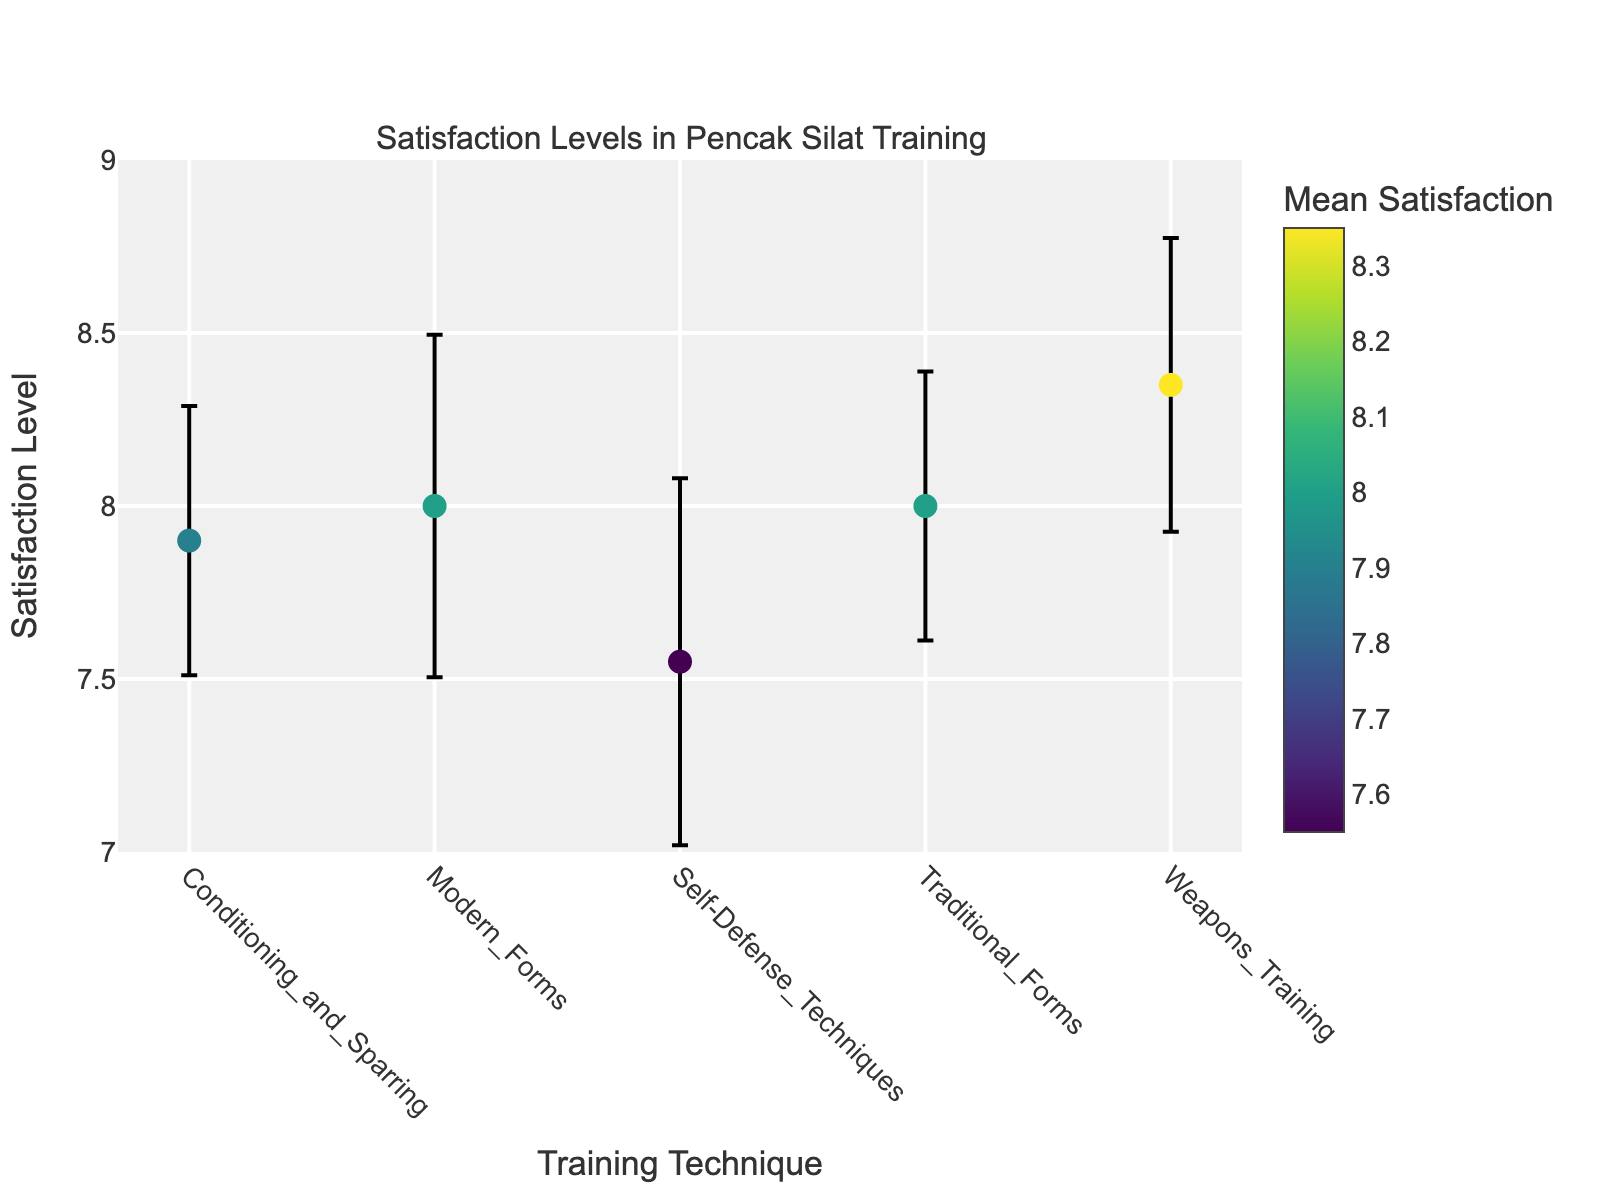What's the title of the plot? The title of the plot is located at the top of the figure. The subplot title is "Satisfaction Levels in Pencak Silat Training".
Answer: Satisfaction Levels in Pencak Silat Training Which training technique has the highest mean satisfaction level? The highest mean satisfaction level can be identified by the dot that is positioned the highest on the y-axis. The technique associated with this dot is Weapons_Training.
Answer: Weapons_Training What's the mean satisfaction level for Traditional_Forms? Locate the point that corresponds to Traditional_Forms on the x-axis, then refer to its position on the y-axis. The mean satisfaction level for Traditional_Forms is around 8.0.
Answer: 8.0 Which technique shows the largest variability in satisfaction level? The largest variability in satisfaction level is indicated by the length of the error bars. Longer error bars suggest higher variability. Modern_Forms has one of the largest variability in satisfaction level.
Answer: Modern_Forms How do the satisfaction levels of Conditioning_and_Sparring compare to Weapons_Training? The y-axis shows the mean satisfaction levels for each technique. Compare the dots for Conditioning_and_Sparring and Weapons_Training. Weapons_Training has a slightly higher mean satisfaction level than Conditioning_and_Sparring.
Answer: Weapons_Training has a higher level What's the mean satisfaction level range across all techniques? Identify the minimum and maximum mean satisfaction levels from the y-axis values of all techniques. The minimum is around 7.55, and the maximum is around 8.35. Therefore, the range is 8.35 - 7.55 = 0.8.
Answer: 0.8 Between Modern_Forms and Self-Defense_Techniques, which technique has a lower mean satisfaction level? Compare the mean satisfaction levels represented by the dots for Modern_Forms and Self-Defense_Techniques. Self-Defense_Techniques has a lower mean satisfaction level (around 7.55) compared to Modern_Forms (around 8.0).
Answer: Self-Defense_Techniques What color scale is used in the plot to indicate mean satisfaction? The dot colors in the plot represent mean satisfaction levels using the 'Viridis' color scale, which ranges from yellow (lower values) to purple (higher values).
Answer: Viridis How many distinct training techniques are compared in the plot? Count the number of distinct labels on the x-axis. The number of distinct training techniques is 5.
Answer: 5 